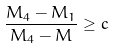Convert formula to latex. <formula><loc_0><loc_0><loc_500><loc_500>\frac { M _ { 4 } - M _ { 1 } } { M _ { 4 } - M } \geq c</formula> 